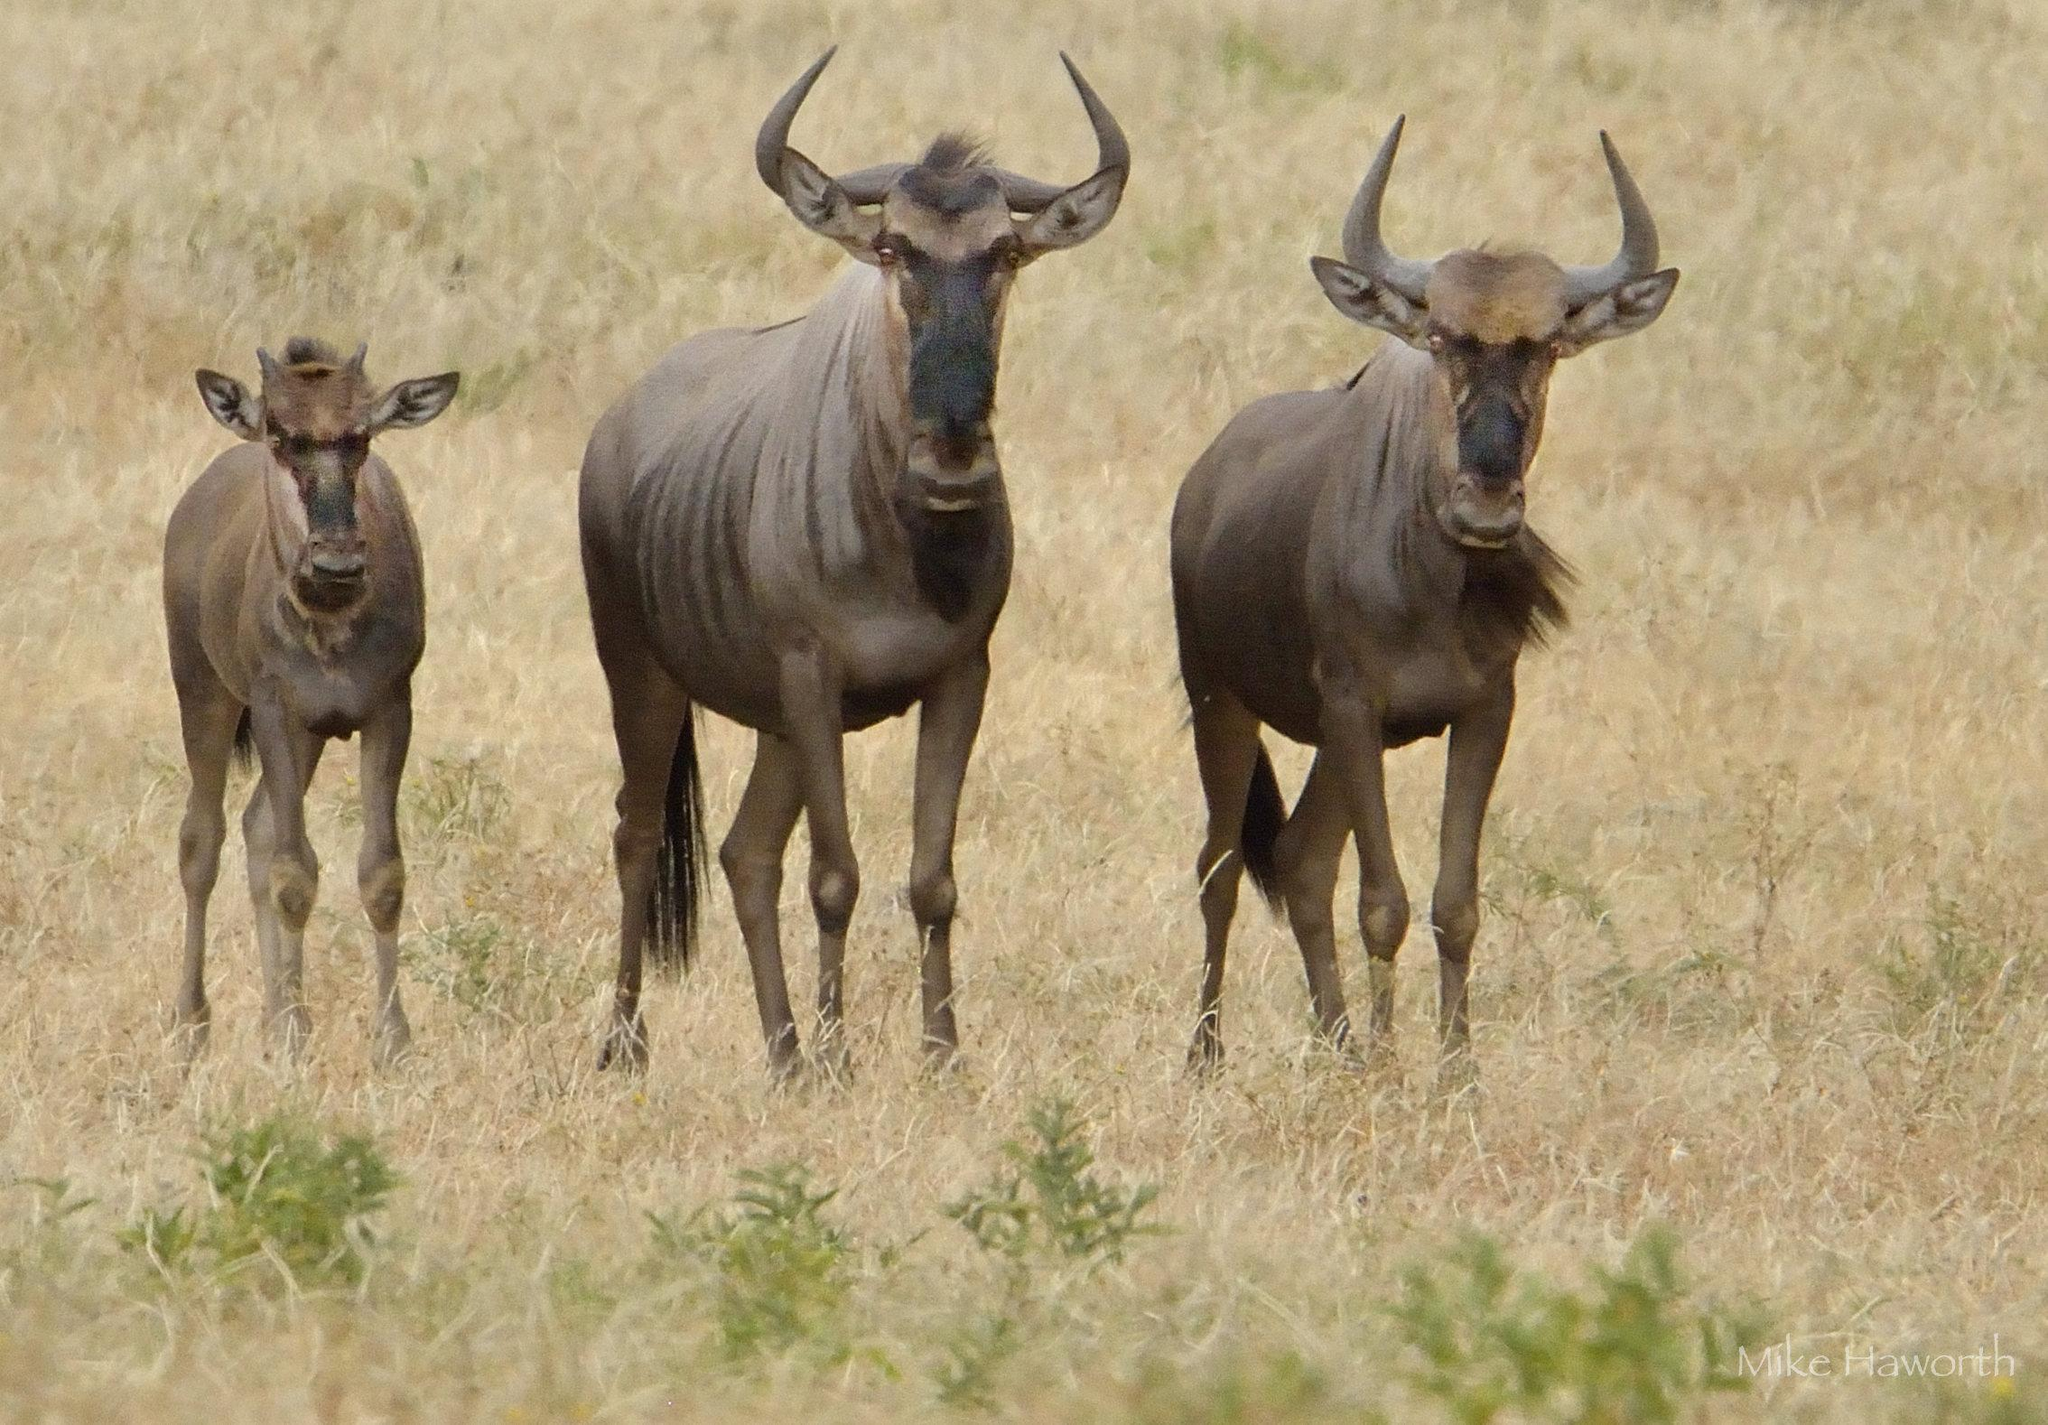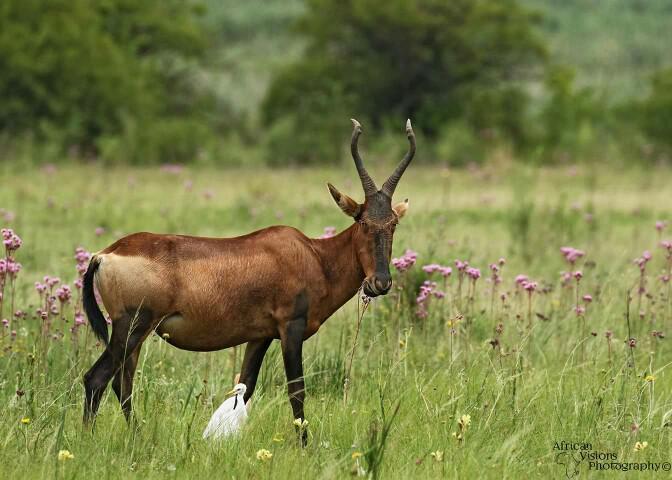The first image is the image on the left, the second image is the image on the right. Evaluate the accuracy of this statement regarding the images: "In at least one image there is a single elk walking right.". Is it true? Answer yes or no. Yes. The first image is the image on the left, the second image is the image on the right. For the images shown, is this caption "One image includes a single adult horned animal, and the other image features a row of horned animals who face the same direction." true? Answer yes or no. Yes. 